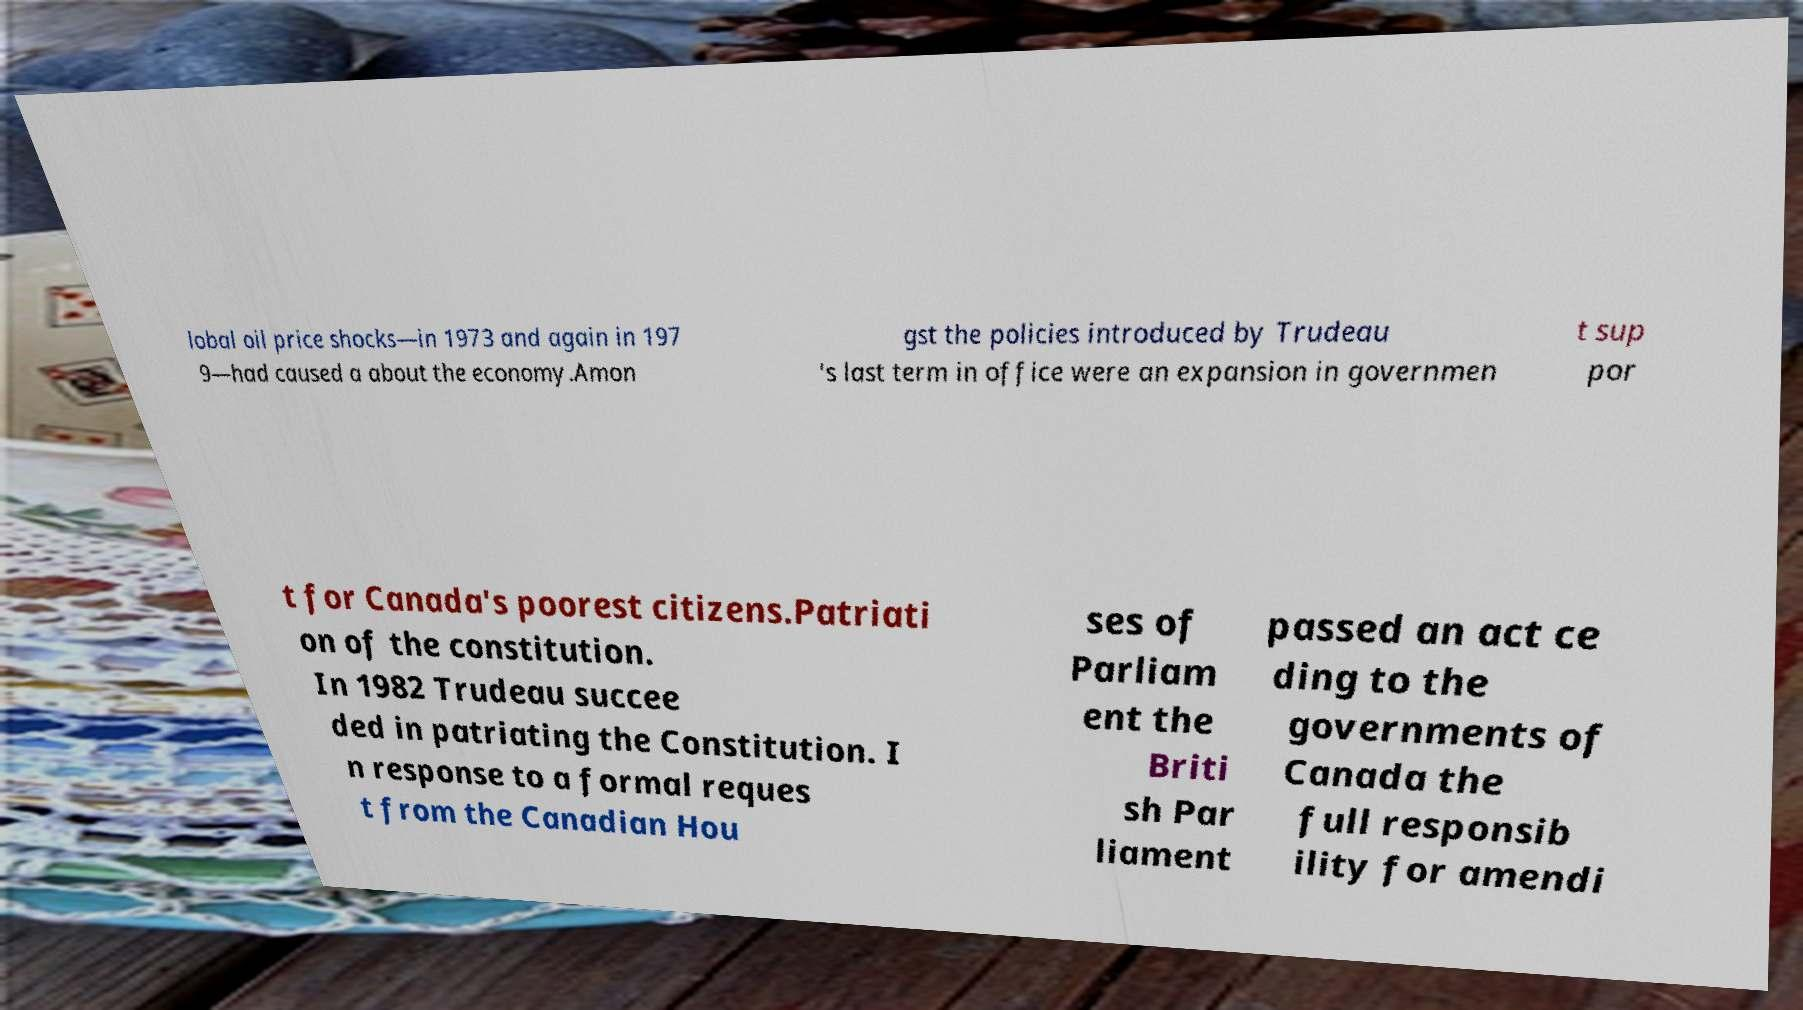I need the written content from this picture converted into text. Can you do that? lobal oil price shocks—in 1973 and again in 197 9—had caused a about the economy.Amon gst the policies introduced by Trudeau 's last term in office were an expansion in governmen t sup por t for Canada's poorest citizens.Patriati on of the constitution. In 1982 Trudeau succee ded in patriating the Constitution. I n response to a formal reques t from the Canadian Hou ses of Parliam ent the Briti sh Par liament passed an act ce ding to the governments of Canada the full responsib ility for amendi 